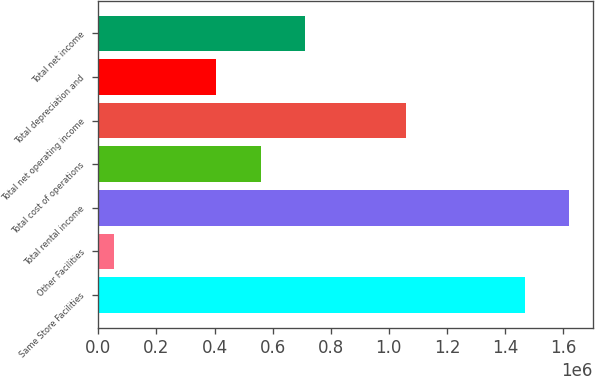Convert chart. <chart><loc_0><loc_0><loc_500><loc_500><bar_chart><fcel>Same Store Facilities<fcel>Other Facilities<fcel>Total rental income<fcel>Total cost of operations<fcel>Total net operating income<fcel>Total depreciation and<fcel>Total net income<nl><fcel>1.46848e+06<fcel>52705<fcel>1.62081e+06<fcel>558404<fcel>1.05816e+06<fcel>406083<fcel>710724<nl></chart> 